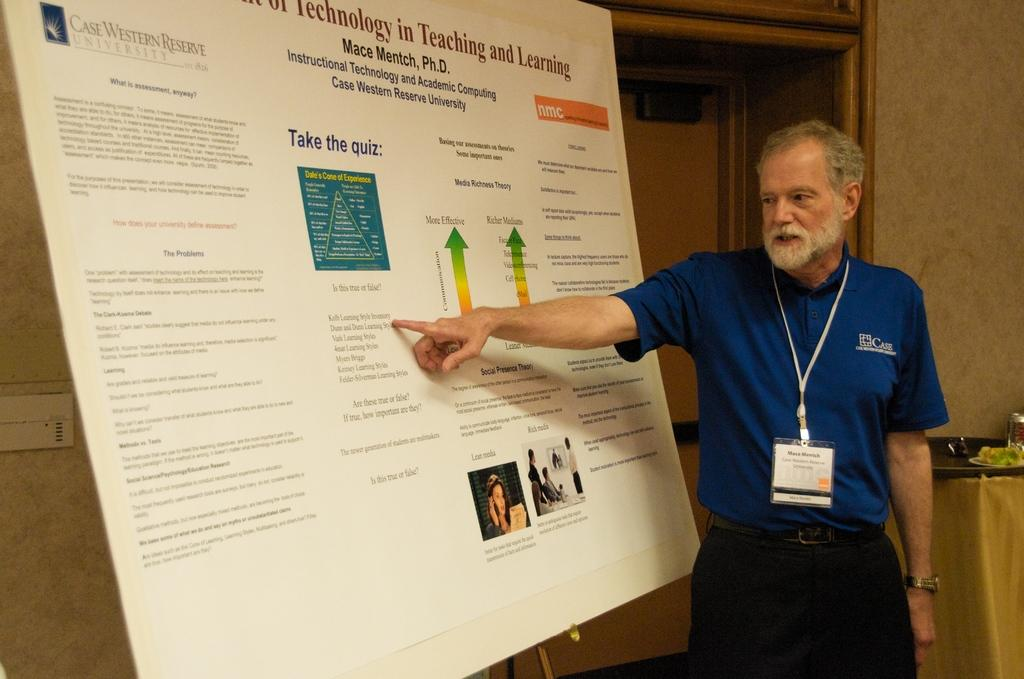Who is in the image? There is a man in the image. What is the man wearing? The man is wearing an ID card. What is the man doing in the image? The man is standing. What is in front of the man? There is a board in front of the man. What can be seen in the background of the image? Walls and objects are visible in the background of the image. How old is the baby in the image? There is no baby present in the image; it features a man standing with a board in front of him. What type of watch is the man wearing in the image? The man is not wearing a watch in the image; he is wearing an ID card. 